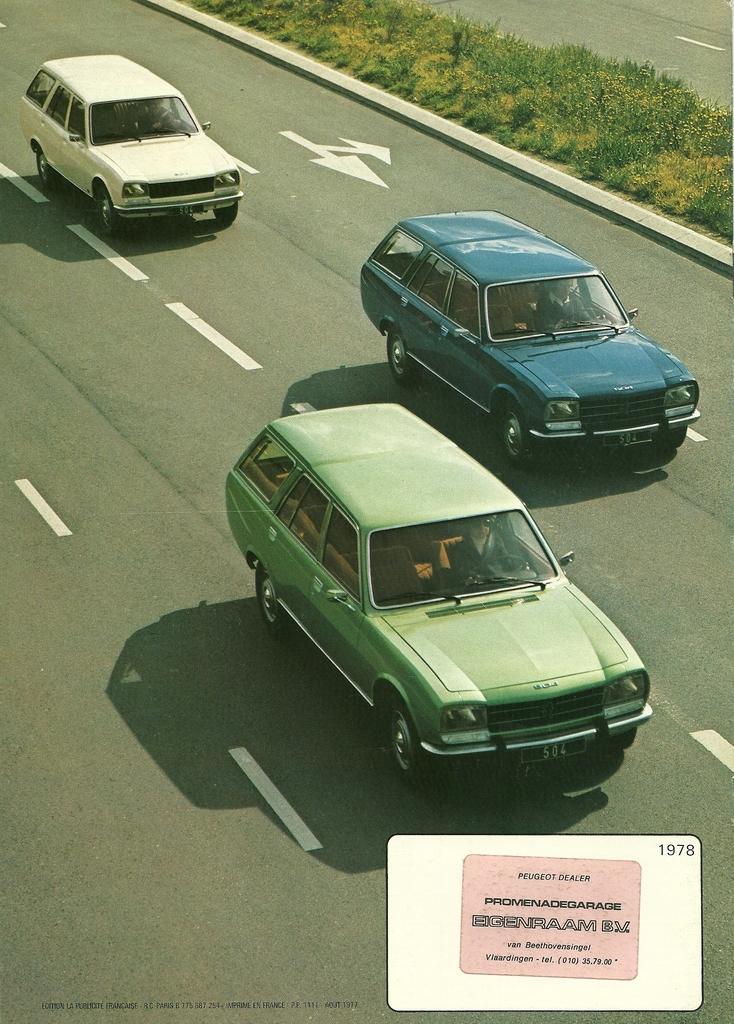In one or two sentences, can you explain what this image depicts? In this picture we can observe three cars on the road. There are green, blue and white color cars. We can observe some plants and grass on the divider. There is a white color box in which we can observe pink color box on the picture. 